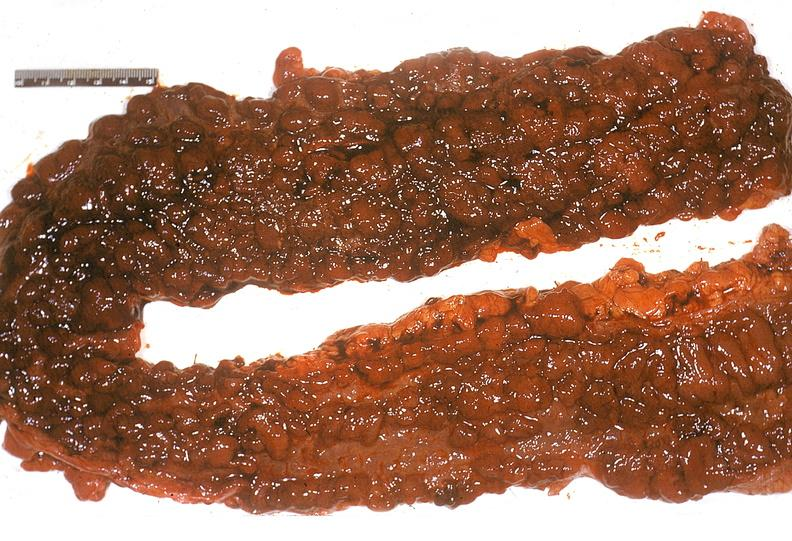where does this belong to?
Answer the question using a single word or phrase. Gastrointestinal system 